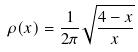<formula> <loc_0><loc_0><loc_500><loc_500>\rho ( x ) = \frac { 1 } { 2 \pi } \sqrt { \frac { 4 - x } { x } }</formula> 